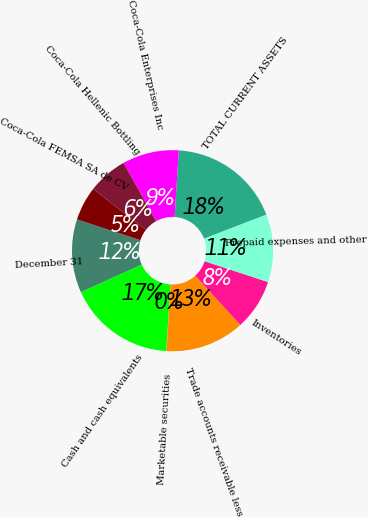Convert chart. <chart><loc_0><loc_0><loc_500><loc_500><pie_chart><fcel>December 31<fcel>Cash and cash equivalents<fcel>Marketable securities<fcel>Trade accounts receivable less<fcel>Inventories<fcel>Prepaid expenses and other<fcel>TOTAL CURRENT ASSETS<fcel>Coca-Cola Enterprises Inc<fcel>Coca-Cola Hellenic Bottling<fcel>Coca-Cola FEMSA SA de CV<nl><fcel>11.81%<fcel>17.24%<fcel>0.05%<fcel>12.71%<fcel>8.19%<fcel>10.9%<fcel>18.14%<fcel>9.1%<fcel>6.38%<fcel>5.48%<nl></chart> 